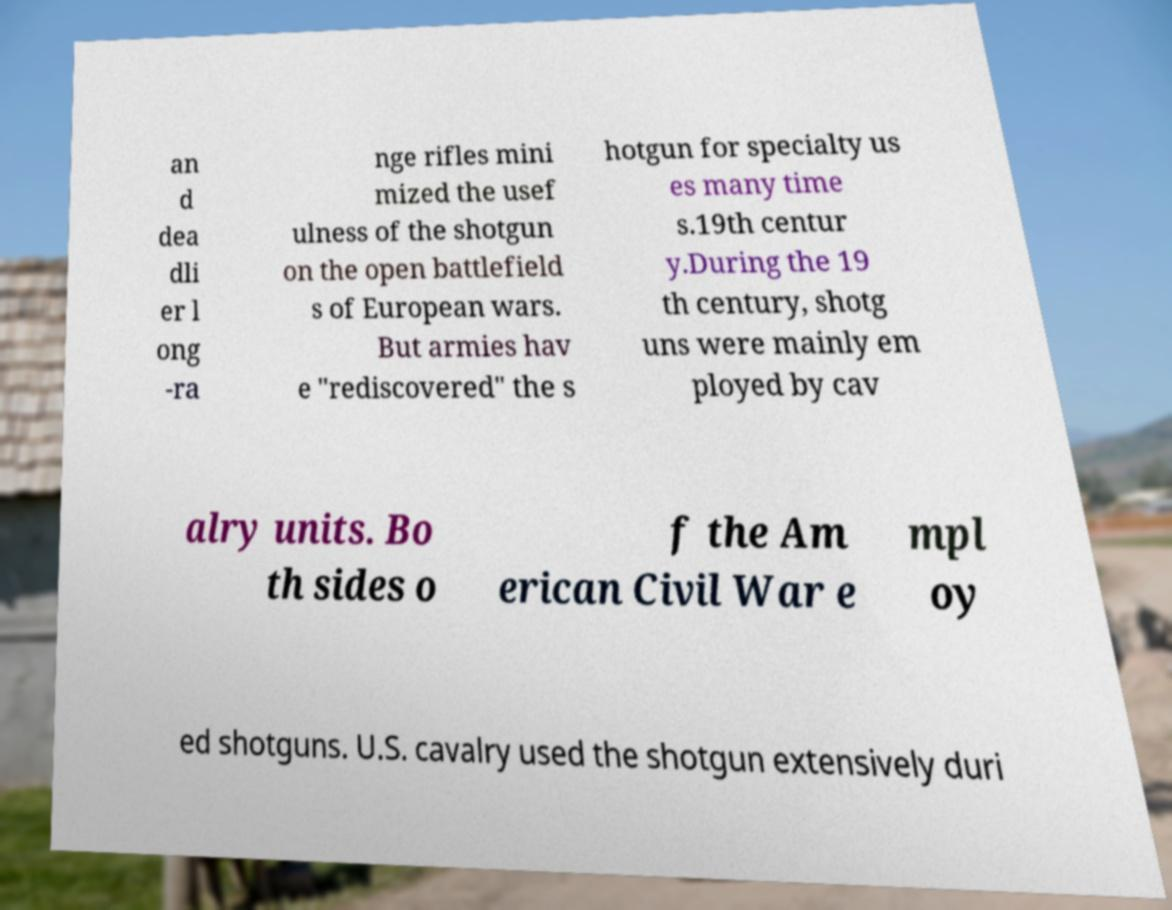Please identify and transcribe the text found in this image. an d dea dli er l ong -ra nge rifles mini mized the usef ulness of the shotgun on the open battlefield s of European wars. But armies hav e "rediscovered" the s hotgun for specialty us es many time s.19th centur y.During the 19 th century, shotg uns were mainly em ployed by cav alry units. Bo th sides o f the Am erican Civil War e mpl oy ed shotguns. U.S. cavalry used the shotgun extensively duri 